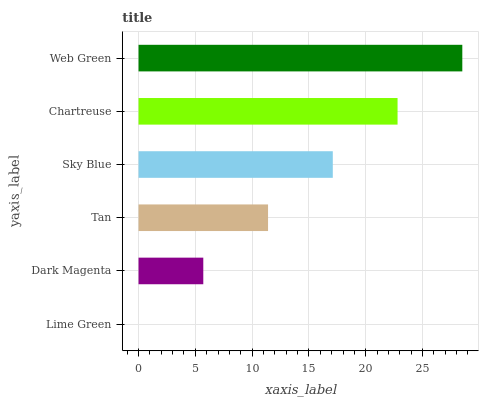Is Lime Green the minimum?
Answer yes or no. Yes. Is Web Green the maximum?
Answer yes or no. Yes. Is Dark Magenta the minimum?
Answer yes or no. No. Is Dark Magenta the maximum?
Answer yes or no. No. Is Dark Magenta greater than Lime Green?
Answer yes or no. Yes. Is Lime Green less than Dark Magenta?
Answer yes or no. Yes. Is Lime Green greater than Dark Magenta?
Answer yes or no. No. Is Dark Magenta less than Lime Green?
Answer yes or no. No. Is Sky Blue the high median?
Answer yes or no. Yes. Is Tan the low median?
Answer yes or no. Yes. Is Web Green the high median?
Answer yes or no. No. Is Dark Magenta the low median?
Answer yes or no. No. 